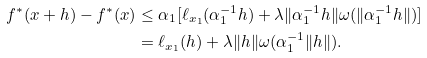<formula> <loc_0><loc_0><loc_500><loc_500>f ^ { * } ( x + h ) - f ^ { * } ( x ) & \leq \alpha _ { 1 } [ \ell _ { x _ { 1 } } ( \alpha _ { 1 } ^ { - 1 } h ) + \lambda \| \alpha _ { 1 } ^ { - 1 } h \| \omega ( \| \alpha _ { 1 } ^ { - 1 } h \| ) ] \\ & = \ell _ { x _ { 1 } } ( h ) + \lambda \| h \| \omega ( \alpha _ { 1 } ^ { - 1 } \| h \| ) .</formula> 